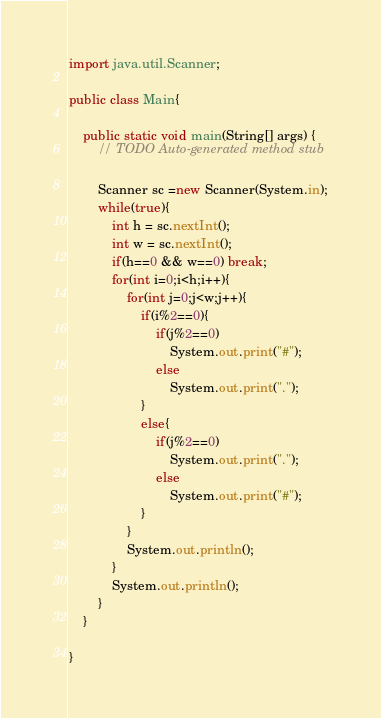<code> <loc_0><loc_0><loc_500><loc_500><_Java_>import java.util.Scanner;

public class Main{

	public static void main(String[] args) {
		// TODO Auto-generated method stub

		Scanner sc =new Scanner(System.in);
		while(true){
			int h = sc.nextInt();
			int w = sc.nextInt();
			if(h==0 && w==0) break;
			for(int i=0;i<h;i++){
				for(int j=0;j<w;j++){
					if(i%2==0){
						if(j%2==0)
							System.out.print("#");
						else
							System.out.print(".");
					}
					else{
						if(j%2==0)
							System.out.print(".");
						else
							System.out.print("#");
					}
				}
				System.out.println();
			}
			System.out.println();
		}
	}

}</code> 